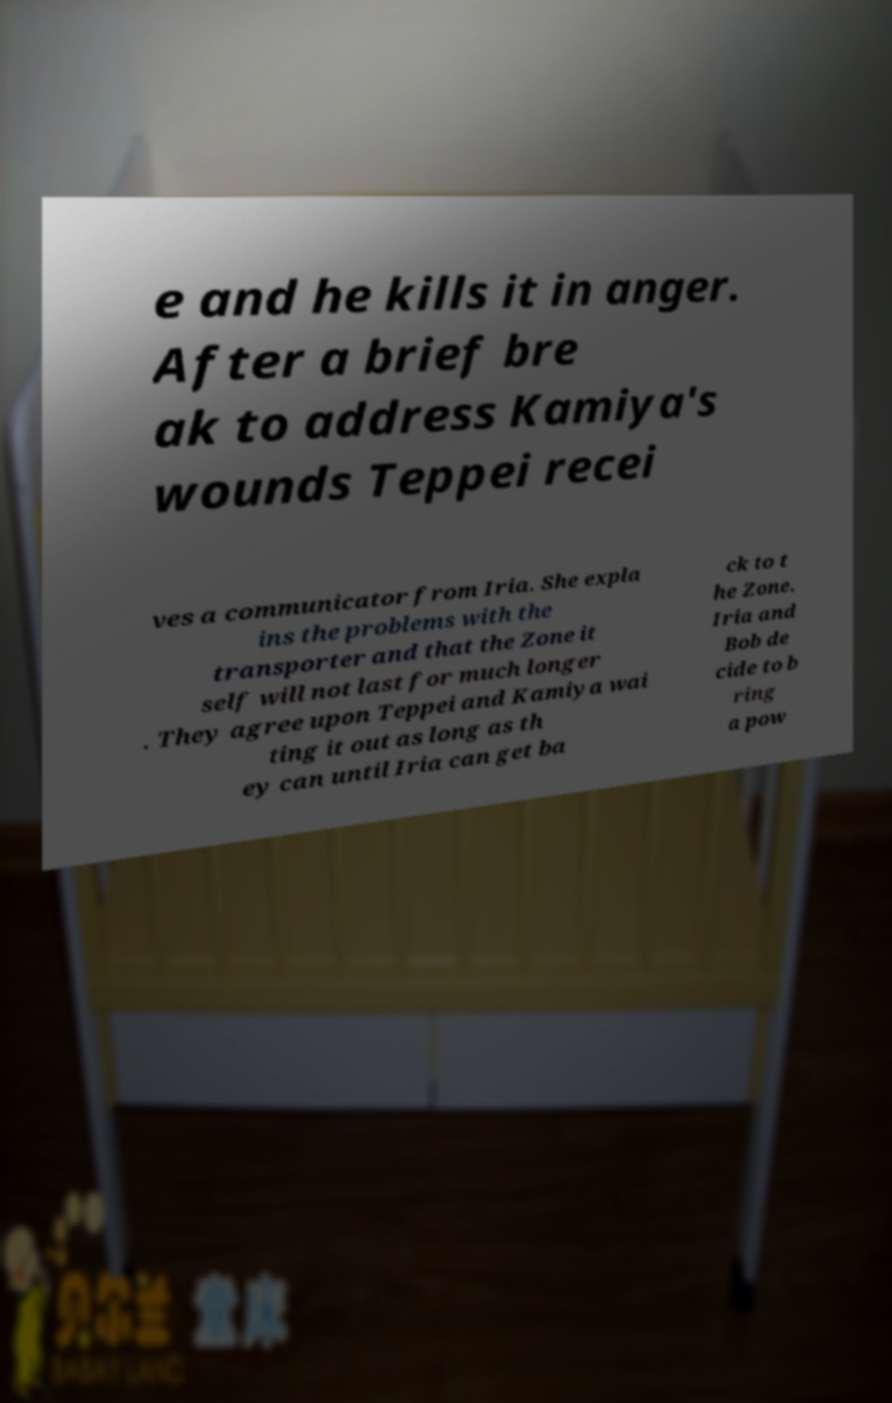What messages or text are displayed in this image? I need them in a readable, typed format. e and he kills it in anger. After a brief bre ak to address Kamiya's wounds Teppei recei ves a communicator from Iria. She expla ins the problems with the transporter and that the Zone it self will not last for much longer . They agree upon Teppei and Kamiya wai ting it out as long as th ey can until Iria can get ba ck to t he Zone. Iria and Bob de cide to b ring a pow 